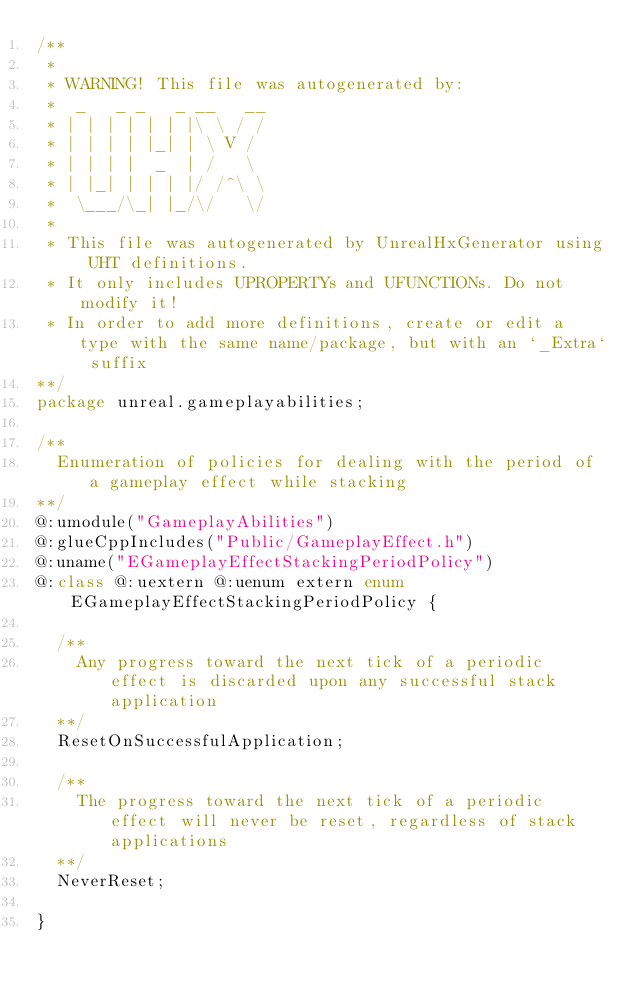Convert code to text. <code><loc_0><loc_0><loc_500><loc_500><_Haxe_>/**
 * 
 * WARNING! This file was autogenerated by: 
 *  _   _ _   _ __   __ 
 * | | | | | | |\ \ / / 
 * | | | | |_| | \ V /  
 * | | | |  _  | /   \  
 * | |_| | | | |/ /^\ \ 
 *  \___/\_| |_/\/   \/ 
 * 
 * This file was autogenerated by UnrealHxGenerator using UHT definitions.
 * It only includes UPROPERTYs and UFUNCTIONs. Do not modify it!
 * In order to add more definitions, create or edit a type with the same name/package, but with an `_Extra` suffix
**/
package unreal.gameplayabilities;

/**
  Enumeration of policies for dealing with the period of a gameplay effect while stacking
**/
@:umodule("GameplayAbilities")
@:glueCppIncludes("Public/GameplayEffect.h")
@:uname("EGameplayEffectStackingPeriodPolicy")
@:class @:uextern @:uenum extern enum EGameplayEffectStackingPeriodPolicy {
  
  /**
    Any progress toward the next tick of a periodic effect is discarded upon any successful stack application
  **/
  ResetOnSuccessfulApplication;
  
  /**
    The progress toward the next tick of a periodic effect will never be reset, regardless of stack applications
  **/
  NeverReset;
  
}
</code> 